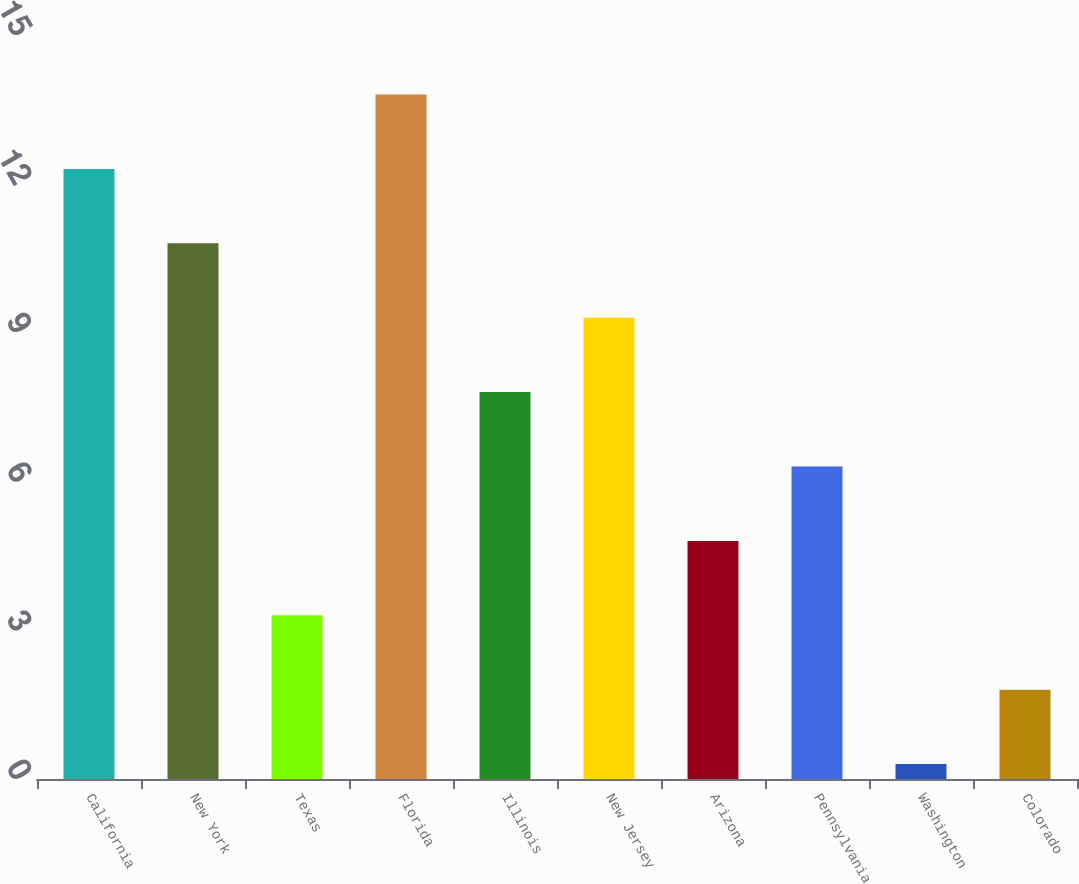Convert chart to OTSL. <chart><loc_0><loc_0><loc_500><loc_500><bar_chart><fcel>California<fcel>New York<fcel>Texas<fcel>Florida<fcel>Illinois<fcel>New Jersey<fcel>Arizona<fcel>Pennsylvania<fcel>Washington<fcel>Colorado<nl><fcel>12.3<fcel>10.8<fcel>3.3<fcel>13.8<fcel>7.8<fcel>9.3<fcel>4.8<fcel>6.3<fcel>0.3<fcel>1.8<nl></chart> 